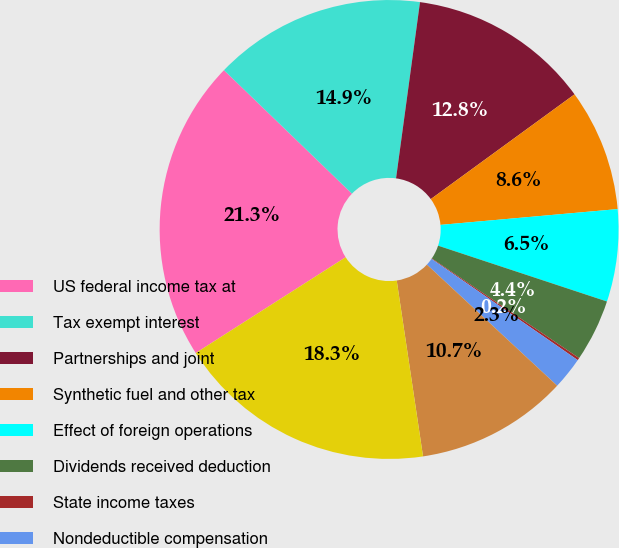Convert chart to OTSL. <chart><loc_0><loc_0><loc_500><loc_500><pie_chart><fcel>US federal income tax at<fcel>Tax exempt interest<fcel>Partnerships and joint<fcel>Synthetic fuel and other tax<fcel>Effect of foreign operations<fcel>Dividends received deduction<fcel>State income taxes<fcel>Nondeductible compensation<fcel>Other<fcel>Actual income tax expense<nl><fcel>21.27%<fcel>14.94%<fcel>12.83%<fcel>8.61%<fcel>6.5%<fcel>4.39%<fcel>0.17%<fcel>2.28%<fcel>10.72%<fcel>18.32%<nl></chart> 